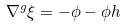Convert formula to latex. <formula><loc_0><loc_0><loc_500><loc_500>\nabla ^ { g } \xi = - \phi - \phi h</formula> 